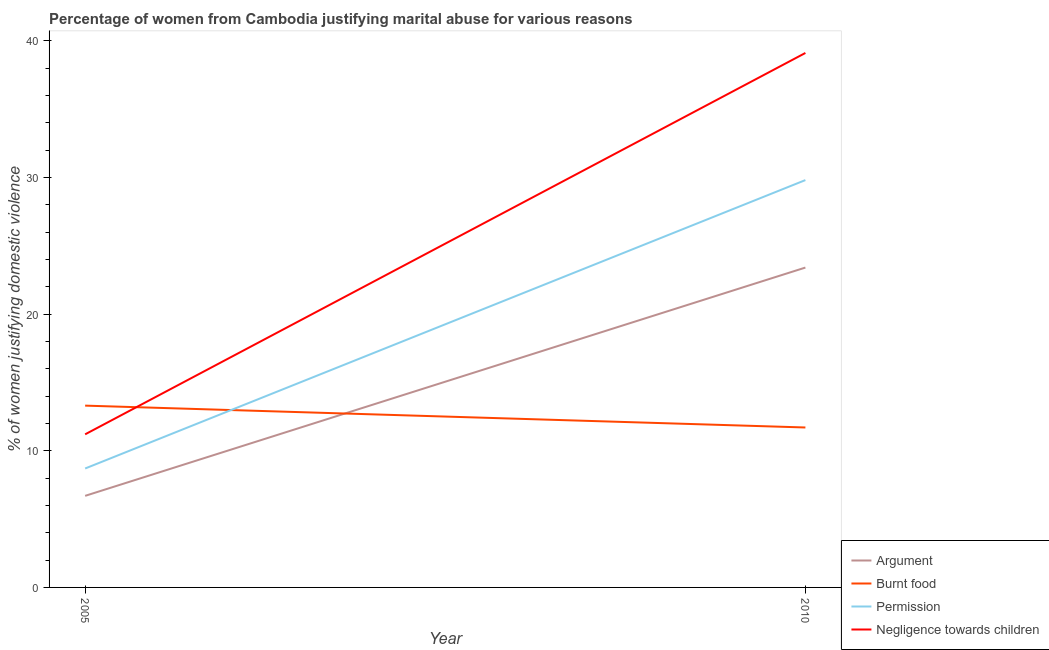How many different coloured lines are there?
Keep it short and to the point. 4. Does the line corresponding to percentage of women justifying abuse for going without permission intersect with the line corresponding to percentage of women justifying abuse for showing negligence towards children?
Your answer should be compact. No. Across all years, what is the maximum percentage of women justifying abuse for burning food?
Provide a succinct answer. 13.3. Across all years, what is the minimum percentage of women justifying abuse for showing negligence towards children?
Your answer should be compact. 11.2. In which year was the percentage of women justifying abuse for showing negligence towards children maximum?
Keep it short and to the point. 2010. What is the total percentage of women justifying abuse in the case of an argument in the graph?
Offer a very short reply. 30.1. What is the difference between the percentage of women justifying abuse for showing negligence towards children in 2005 and that in 2010?
Offer a terse response. -27.9. What is the difference between the percentage of women justifying abuse in the case of an argument in 2005 and the percentage of women justifying abuse for burning food in 2010?
Keep it short and to the point. -5. What is the average percentage of women justifying abuse in the case of an argument per year?
Offer a terse response. 15.05. In the year 2005, what is the difference between the percentage of women justifying abuse in the case of an argument and percentage of women justifying abuse for going without permission?
Offer a terse response. -2. What is the ratio of the percentage of women justifying abuse in the case of an argument in 2005 to that in 2010?
Your answer should be compact. 0.29. Is it the case that in every year, the sum of the percentage of women justifying abuse for going without permission and percentage of women justifying abuse in the case of an argument is greater than the sum of percentage of women justifying abuse for burning food and percentage of women justifying abuse for showing negligence towards children?
Provide a succinct answer. Yes. Is it the case that in every year, the sum of the percentage of women justifying abuse in the case of an argument and percentage of women justifying abuse for burning food is greater than the percentage of women justifying abuse for going without permission?
Your answer should be very brief. Yes. Does the percentage of women justifying abuse for showing negligence towards children monotonically increase over the years?
Provide a short and direct response. Yes. Is the percentage of women justifying abuse for showing negligence towards children strictly less than the percentage of women justifying abuse in the case of an argument over the years?
Keep it short and to the point. No. How many years are there in the graph?
Your response must be concise. 2. Are the values on the major ticks of Y-axis written in scientific E-notation?
Your answer should be compact. No. Does the graph contain any zero values?
Your answer should be compact. No. How many legend labels are there?
Make the answer very short. 4. What is the title of the graph?
Offer a very short reply. Percentage of women from Cambodia justifying marital abuse for various reasons. Does "Third 20% of population" appear as one of the legend labels in the graph?
Your answer should be very brief. No. What is the label or title of the Y-axis?
Offer a very short reply. % of women justifying domestic violence. What is the % of women justifying domestic violence in Argument in 2005?
Offer a very short reply. 6.7. What is the % of women justifying domestic violence of Negligence towards children in 2005?
Provide a succinct answer. 11.2. What is the % of women justifying domestic violence of Argument in 2010?
Make the answer very short. 23.4. What is the % of women justifying domestic violence in Permission in 2010?
Your answer should be compact. 29.8. What is the % of women justifying domestic violence in Negligence towards children in 2010?
Keep it short and to the point. 39.1. Across all years, what is the maximum % of women justifying domestic violence of Argument?
Give a very brief answer. 23.4. Across all years, what is the maximum % of women justifying domestic violence of Permission?
Provide a short and direct response. 29.8. Across all years, what is the maximum % of women justifying domestic violence in Negligence towards children?
Keep it short and to the point. 39.1. Across all years, what is the minimum % of women justifying domestic violence in Argument?
Ensure brevity in your answer.  6.7. Across all years, what is the minimum % of women justifying domestic violence of Burnt food?
Keep it short and to the point. 11.7. Across all years, what is the minimum % of women justifying domestic violence in Permission?
Your answer should be compact. 8.7. Across all years, what is the minimum % of women justifying domestic violence of Negligence towards children?
Make the answer very short. 11.2. What is the total % of women justifying domestic violence in Argument in the graph?
Ensure brevity in your answer.  30.1. What is the total % of women justifying domestic violence of Permission in the graph?
Give a very brief answer. 38.5. What is the total % of women justifying domestic violence in Negligence towards children in the graph?
Keep it short and to the point. 50.3. What is the difference between the % of women justifying domestic violence in Argument in 2005 and that in 2010?
Offer a very short reply. -16.7. What is the difference between the % of women justifying domestic violence in Burnt food in 2005 and that in 2010?
Make the answer very short. 1.6. What is the difference between the % of women justifying domestic violence in Permission in 2005 and that in 2010?
Offer a very short reply. -21.1. What is the difference between the % of women justifying domestic violence of Negligence towards children in 2005 and that in 2010?
Give a very brief answer. -27.9. What is the difference between the % of women justifying domestic violence of Argument in 2005 and the % of women justifying domestic violence of Burnt food in 2010?
Provide a short and direct response. -5. What is the difference between the % of women justifying domestic violence in Argument in 2005 and the % of women justifying domestic violence in Permission in 2010?
Your answer should be compact. -23.1. What is the difference between the % of women justifying domestic violence in Argument in 2005 and the % of women justifying domestic violence in Negligence towards children in 2010?
Offer a terse response. -32.4. What is the difference between the % of women justifying domestic violence of Burnt food in 2005 and the % of women justifying domestic violence of Permission in 2010?
Provide a short and direct response. -16.5. What is the difference between the % of women justifying domestic violence of Burnt food in 2005 and the % of women justifying domestic violence of Negligence towards children in 2010?
Give a very brief answer. -25.8. What is the difference between the % of women justifying domestic violence of Permission in 2005 and the % of women justifying domestic violence of Negligence towards children in 2010?
Keep it short and to the point. -30.4. What is the average % of women justifying domestic violence of Argument per year?
Your answer should be very brief. 15.05. What is the average % of women justifying domestic violence of Permission per year?
Your answer should be compact. 19.25. What is the average % of women justifying domestic violence of Negligence towards children per year?
Offer a very short reply. 25.15. In the year 2005, what is the difference between the % of women justifying domestic violence of Argument and % of women justifying domestic violence of Burnt food?
Your answer should be compact. -6.6. In the year 2005, what is the difference between the % of women justifying domestic violence in Argument and % of women justifying domestic violence in Permission?
Ensure brevity in your answer.  -2. In the year 2005, what is the difference between the % of women justifying domestic violence of Burnt food and % of women justifying domestic violence of Permission?
Make the answer very short. 4.6. In the year 2005, what is the difference between the % of women justifying domestic violence of Burnt food and % of women justifying domestic violence of Negligence towards children?
Give a very brief answer. 2.1. In the year 2010, what is the difference between the % of women justifying domestic violence in Argument and % of women justifying domestic violence in Permission?
Ensure brevity in your answer.  -6.4. In the year 2010, what is the difference between the % of women justifying domestic violence in Argument and % of women justifying domestic violence in Negligence towards children?
Your answer should be compact. -15.7. In the year 2010, what is the difference between the % of women justifying domestic violence in Burnt food and % of women justifying domestic violence in Permission?
Provide a short and direct response. -18.1. In the year 2010, what is the difference between the % of women justifying domestic violence in Burnt food and % of women justifying domestic violence in Negligence towards children?
Provide a short and direct response. -27.4. What is the ratio of the % of women justifying domestic violence in Argument in 2005 to that in 2010?
Your answer should be very brief. 0.29. What is the ratio of the % of women justifying domestic violence in Burnt food in 2005 to that in 2010?
Your answer should be compact. 1.14. What is the ratio of the % of women justifying domestic violence in Permission in 2005 to that in 2010?
Ensure brevity in your answer.  0.29. What is the ratio of the % of women justifying domestic violence in Negligence towards children in 2005 to that in 2010?
Ensure brevity in your answer.  0.29. What is the difference between the highest and the second highest % of women justifying domestic violence of Burnt food?
Give a very brief answer. 1.6. What is the difference between the highest and the second highest % of women justifying domestic violence in Permission?
Your response must be concise. 21.1. What is the difference between the highest and the second highest % of women justifying domestic violence in Negligence towards children?
Ensure brevity in your answer.  27.9. What is the difference between the highest and the lowest % of women justifying domestic violence of Argument?
Ensure brevity in your answer.  16.7. What is the difference between the highest and the lowest % of women justifying domestic violence of Permission?
Your response must be concise. 21.1. What is the difference between the highest and the lowest % of women justifying domestic violence of Negligence towards children?
Give a very brief answer. 27.9. 